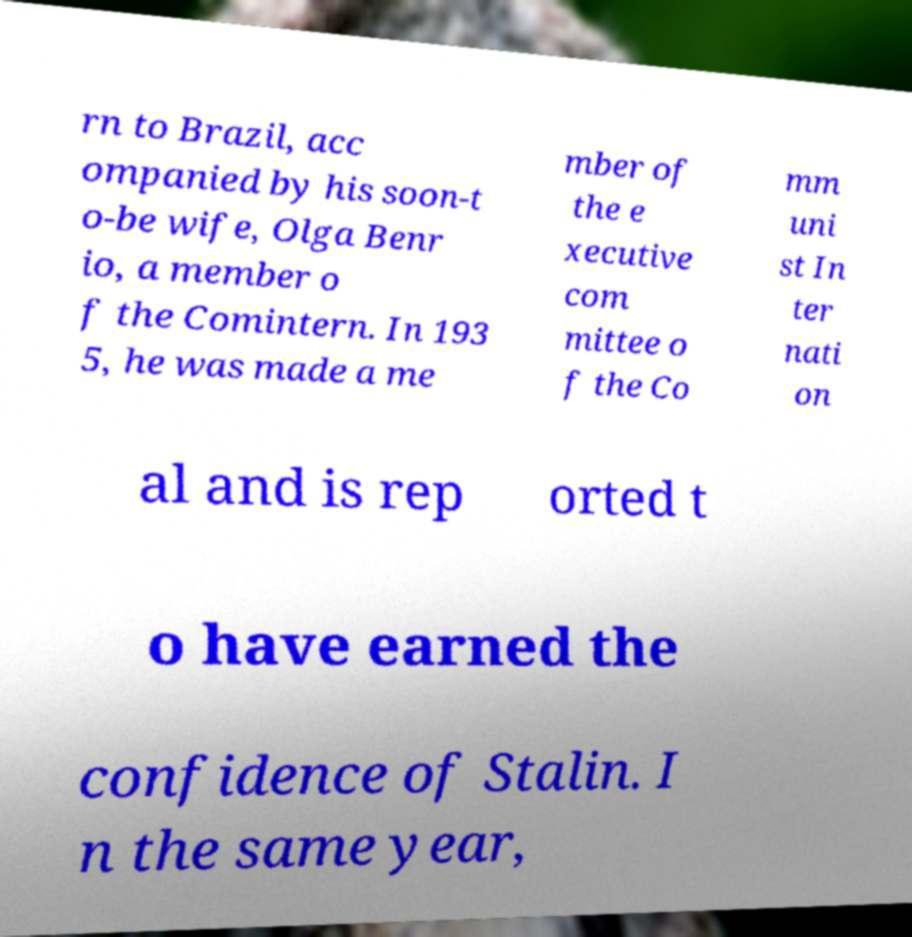Please identify and transcribe the text found in this image. rn to Brazil, acc ompanied by his soon-t o-be wife, Olga Benr io, a member o f the Comintern. In 193 5, he was made a me mber of the e xecutive com mittee o f the Co mm uni st In ter nati on al and is rep orted t o have earned the confidence of Stalin. I n the same year, 